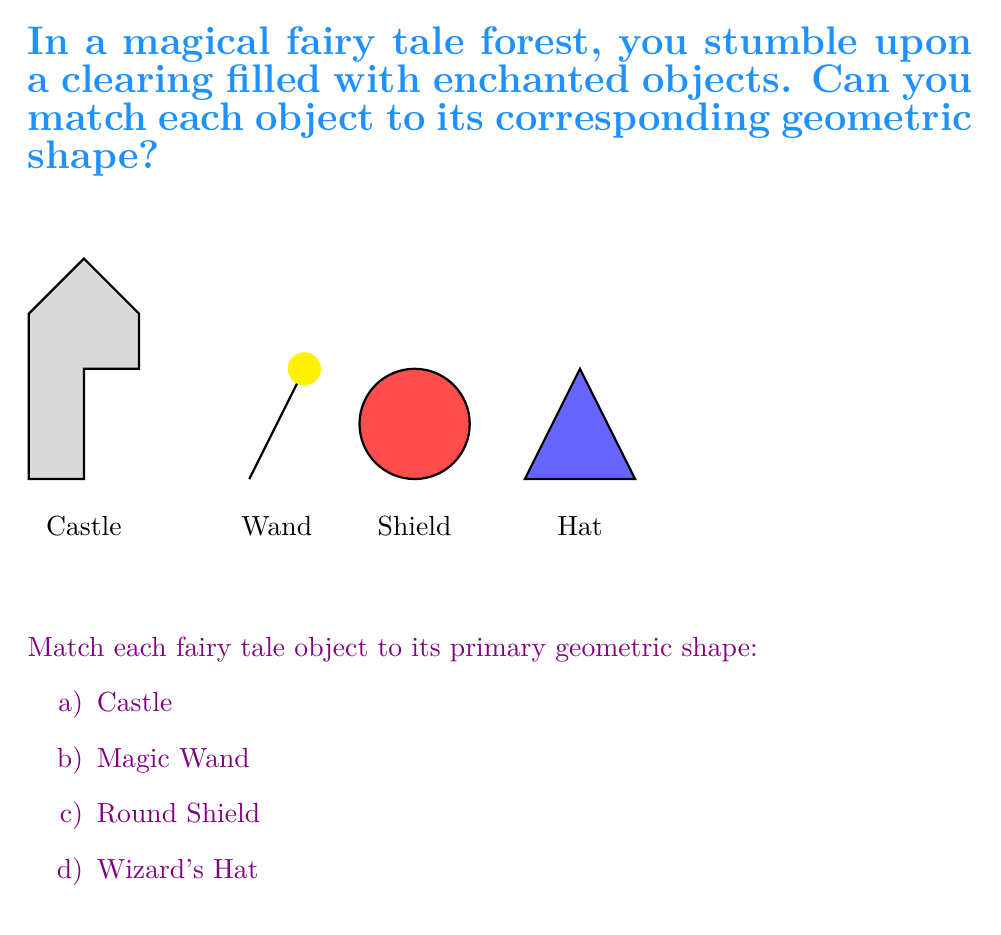Show me your answer to this math problem. Let's analyze each object and match it to its primary geometric shape:

1. Castle: The castle's main structure is composed of rectangular shapes. The towers and walls form a series of connected rectangles. Therefore, the primary geometric shape for the castle is a rectangle.

2. Magic Wand: The wand is represented by a straight line with a circular tip. While the tip is a circle, the primary shape that defines the wand's overall structure is a line segment.

3. Round Shield: This object is clearly circular in shape. It's a perfect representation of a circle in our fairy tale setting.

4. Wizard's Hat: The hat has a distinctive triangular shape. It's formed by connecting three points to create a triangle.

To summarize:
a) Castle → Rectangle
b) Magic Wand → Line segment
c) Round Shield → Circle
d) Wizard's Hat → Triangle
Answer: a) Rectangle, b) Line segment, c) Circle, d) Triangle 